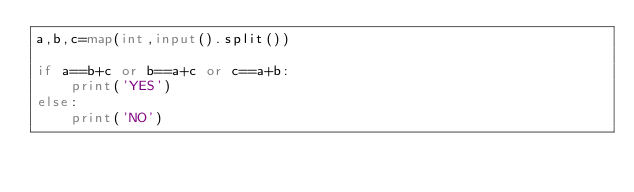Convert code to text. <code><loc_0><loc_0><loc_500><loc_500><_Python_>a,b,c=map(int,input().split())

if a==b+c or b==a+c or c==a+b:
    print('YES')
else:
    print('NO')</code> 